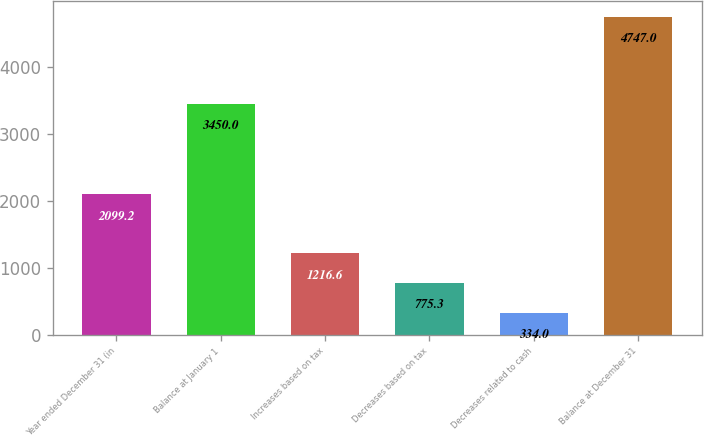<chart> <loc_0><loc_0><loc_500><loc_500><bar_chart><fcel>Year ended December 31 (in<fcel>Balance at January 1<fcel>Increases based on tax<fcel>Decreases based on tax<fcel>Decreases related to cash<fcel>Balance at December 31<nl><fcel>2099.2<fcel>3450<fcel>1216.6<fcel>775.3<fcel>334<fcel>4747<nl></chart> 